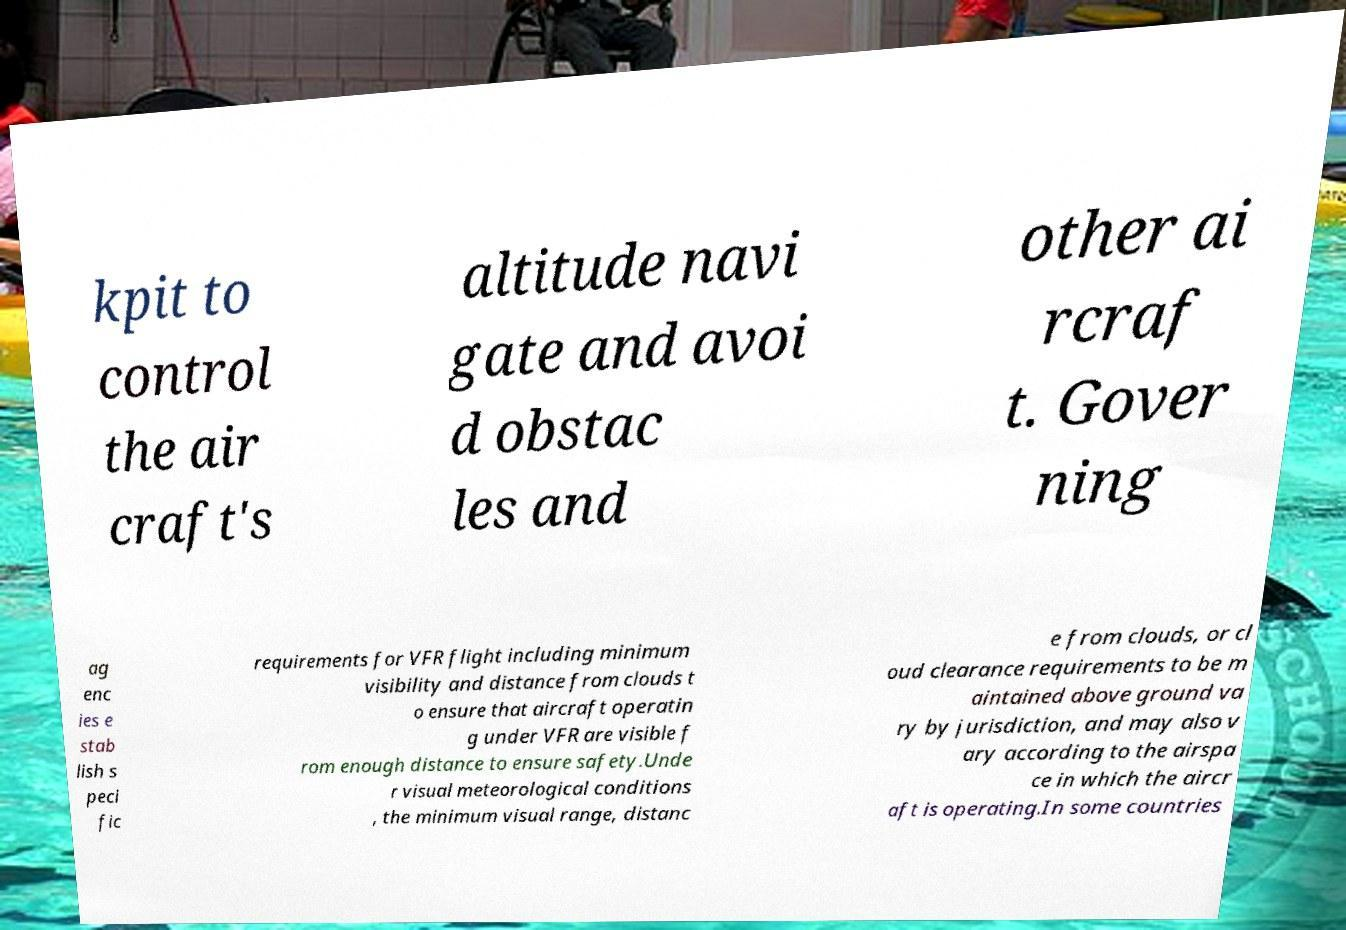Please read and relay the text visible in this image. What does it say? kpit to control the air craft's altitude navi gate and avoi d obstac les and other ai rcraf t. Gover ning ag enc ies e stab lish s peci fic requirements for VFR flight including minimum visibility and distance from clouds t o ensure that aircraft operatin g under VFR are visible f rom enough distance to ensure safety.Unde r visual meteorological conditions , the minimum visual range, distanc e from clouds, or cl oud clearance requirements to be m aintained above ground va ry by jurisdiction, and may also v ary according to the airspa ce in which the aircr aft is operating.In some countries 